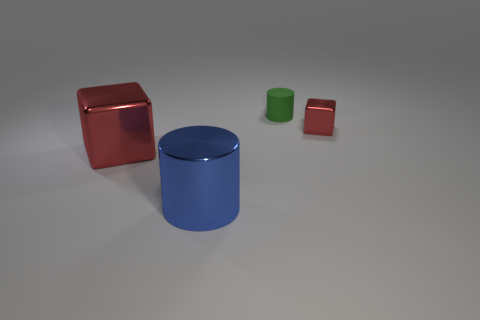Add 4 tiny green metallic spheres. How many objects exist? 8 Add 4 metal cylinders. How many metal cylinders are left? 5 Add 3 big gray blocks. How many big gray blocks exist? 3 Subtract 1 green cylinders. How many objects are left? 3 Subtract all green things. Subtract all blue cylinders. How many objects are left? 2 